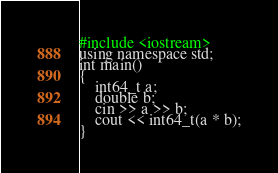<code> <loc_0><loc_0><loc_500><loc_500><_Python_>#include <iostream>
using namespace std;
int main()
{
    int64_t a;
    double b;
    cin >> a >> b;
    cout << int64_t(a * b);
}</code> 